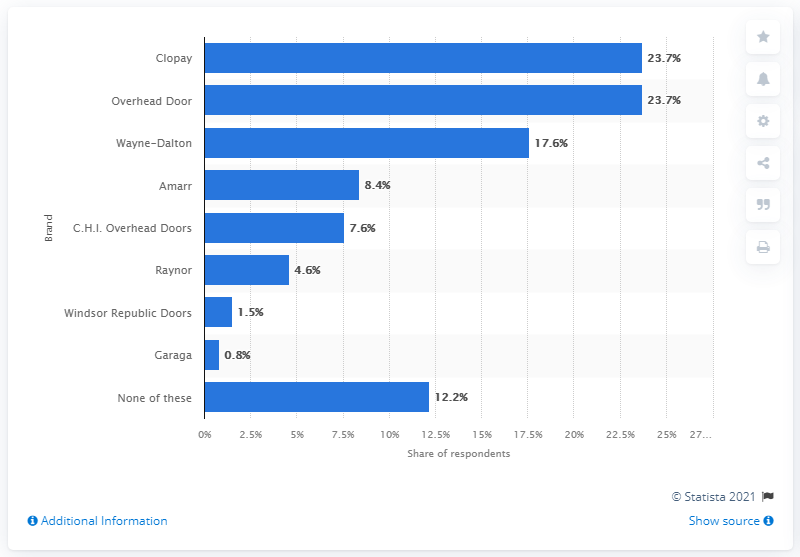Highlight a few significant elements in this photo. According to the survey, Wayne-Dalton was the brand of garage doors that was used most by 17.6% of respondents. 